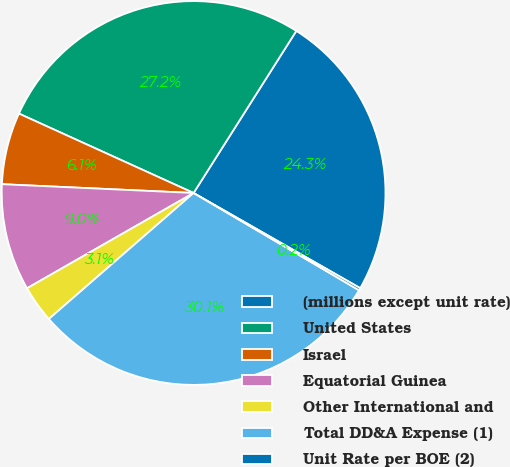Convert chart to OTSL. <chart><loc_0><loc_0><loc_500><loc_500><pie_chart><fcel>(millions except unit rate)<fcel>United States<fcel>Israel<fcel>Equatorial Guinea<fcel>Other International and<fcel>Total DD&A Expense (1)<fcel>Unit Rate per BOE (2)<nl><fcel>24.27%<fcel>27.2%<fcel>6.06%<fcel>9.0%<fcel>3.13%<fcel>30.14%<fcel>0.2%<nl></chart> 